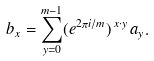Convert formula to latex. <formula><loc_0><loc_0><loc_500><loc_500>b _ { x } = \sum _ { y = 0 } ^ { m - 1 } ( e ^ { 2 \pi i / m } ) ^ { \, x \cdot y } \, a _ { y } .</formula> 